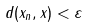Convert formula to latex. <formula><loc_0><loc_0><loc_500><loc_500>d ( x _ { n } , x ) < \varepsilon</formula> 